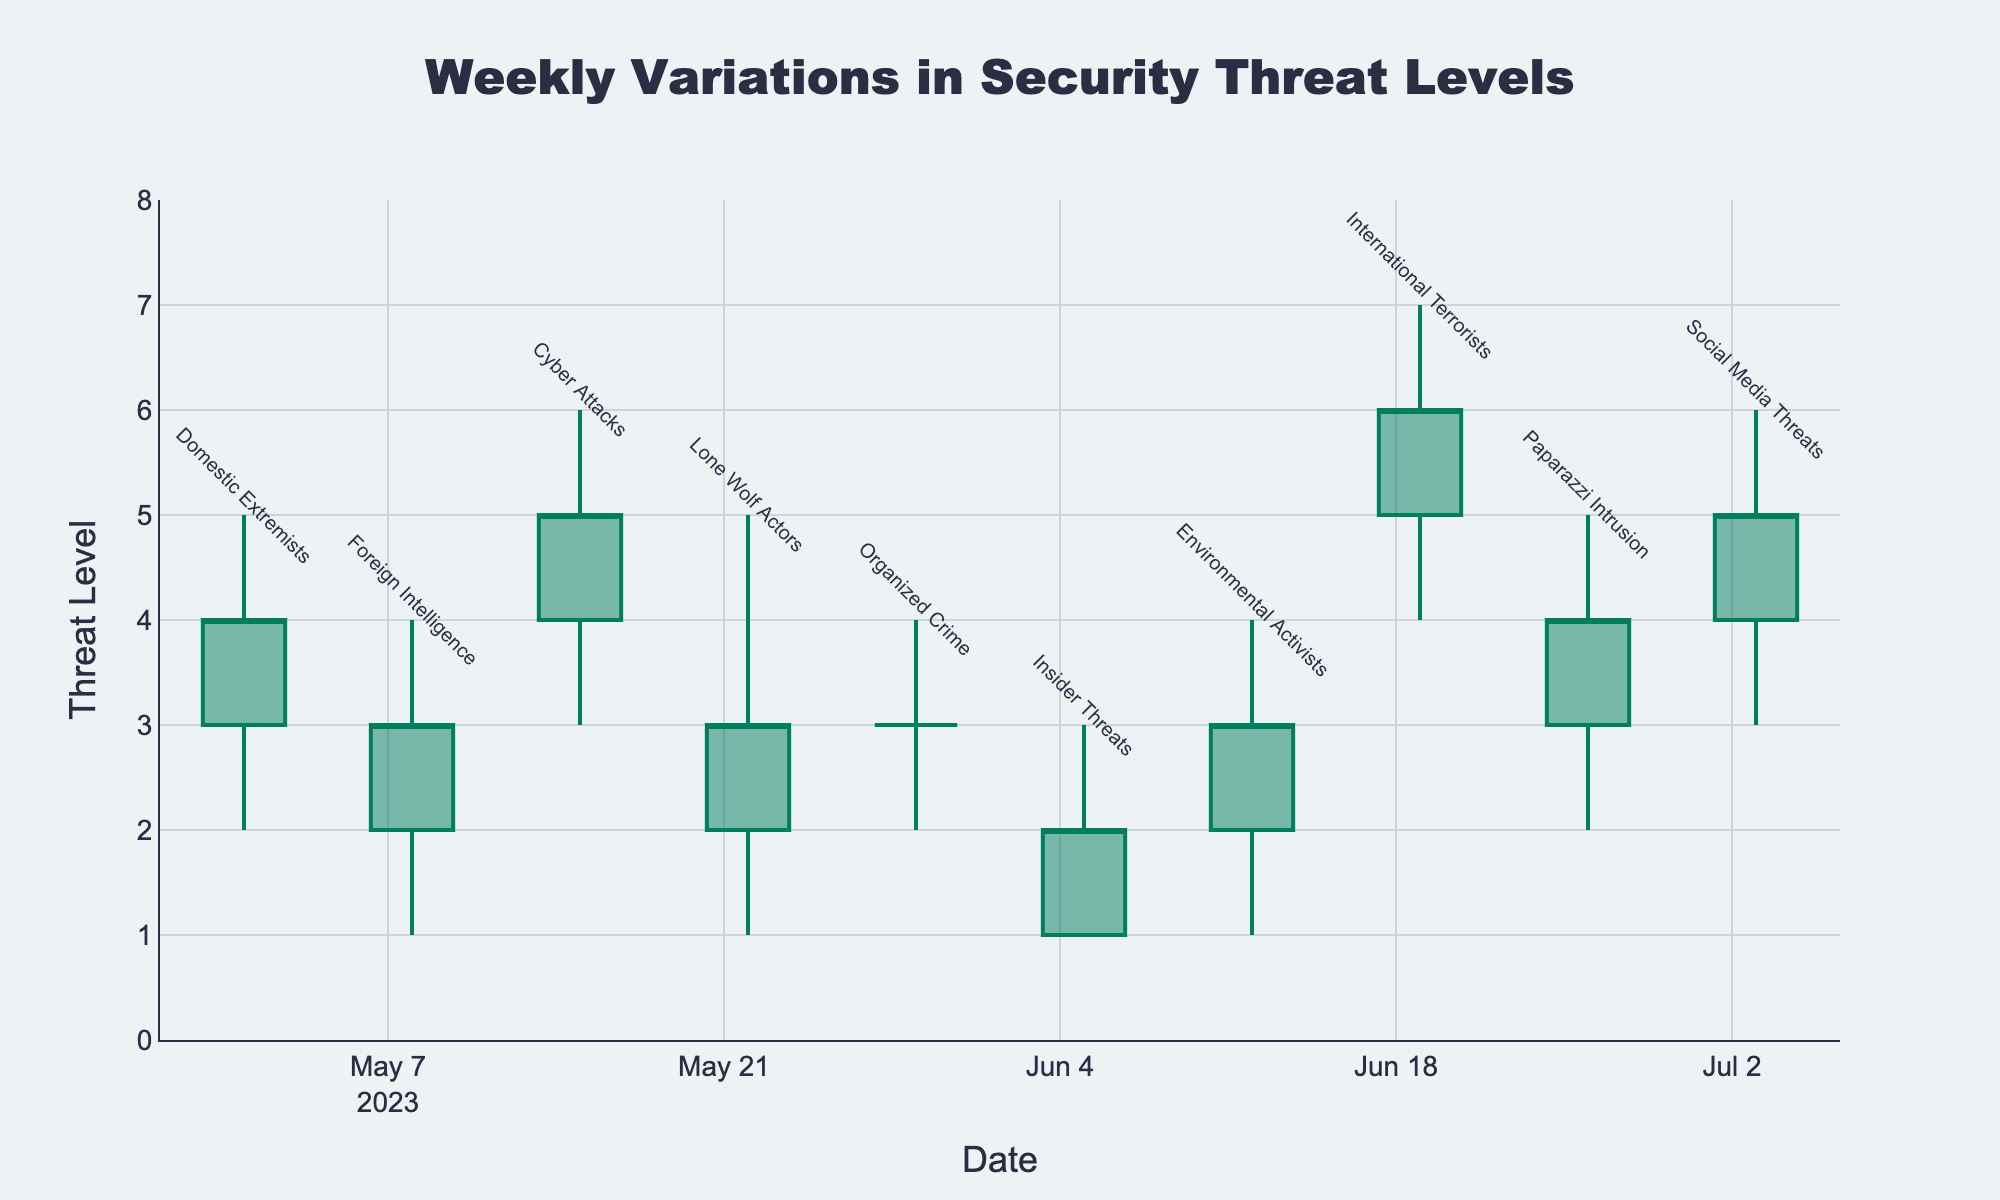What is the title of the chart? The title of the chart is displayed at the top and centered. The text reads "Weekly Variations in Security Threat Levels".
Answer: Weekly Variations in Security Threat Levels What is the highest threat level recorded, and which source does it correspond to? The highest threat level can be observed by looking for the highest "High" value in the chart. The highest value noted is 7, which corresponds to the "International Terrorists" threat source.
Answer: 7, International Terrorists Which threat source had the smallest range of variation in their threat levels? To determine the smallest range of variation, we should identify the difference between the highest and lowest threat levels for each source. The smallest range is from a low of 1 to a high of 1, corresponding to the "Insider Threats" where variation is zero.
Answer: Insider Threats Which weeks experienced an increase in threat levels from open to close values? To identify weeks with an increase, look for weeks where the open value is less than the close value. The weeks corresponding to this condition are May 1 (Domestic Extremists), May 15 (Cyber Attacks), June 19 (International Terrorists), and July 3 (Social Media Threats).
Answer: Weeks of May 1, May 15, June 19, July 3 What was the difference between the highest threat level and the lowest threat level recorded for Cyber Attacks? For Cyber Attacks, the high value is 6 and the low value is 3. The difference is calculated as 6 - 3 = 3.
Answer: 3 Compare the threat levels for "Domestic Extremists" and "Paparazzi Intrusion". Which one had a higher closing value? To compare, we need to look at the closing values for both sources. Domestic Extremists closed at 4, while Paparazzi Intrusion also closed at 4. Therefore, both had the same closing value.
Answer: Both had the same closing value Which threat source had the highest opening value, and what was it? The highest opening value can be identified by checking the open values in the chart. "International Terrorists" had the highest opening value of 5.
Answer: International Terrorists, 5 How many different categories of threat sources are shown in the chart? The number of distinct threat sources can be counted from the annotations or the data points. There are 10 distinct categories listed.
Answer: 10 Did "Organized Crime" experience any variation in its threat level throughout the week? To determine this, look at the high and low values for "Organized Crime". Both high and low values are different (high of 4 and low of 2), indicating some variation.
Answer: Yes What was the average high value recorded across all threat sources? To find the average, sum the high values and divide by the total number of data points. The sum of high values is 5+4+6+5+4+3+4+7+5+6 = 49. The average is 49/10 = 4.9.
Answer: 4.9 